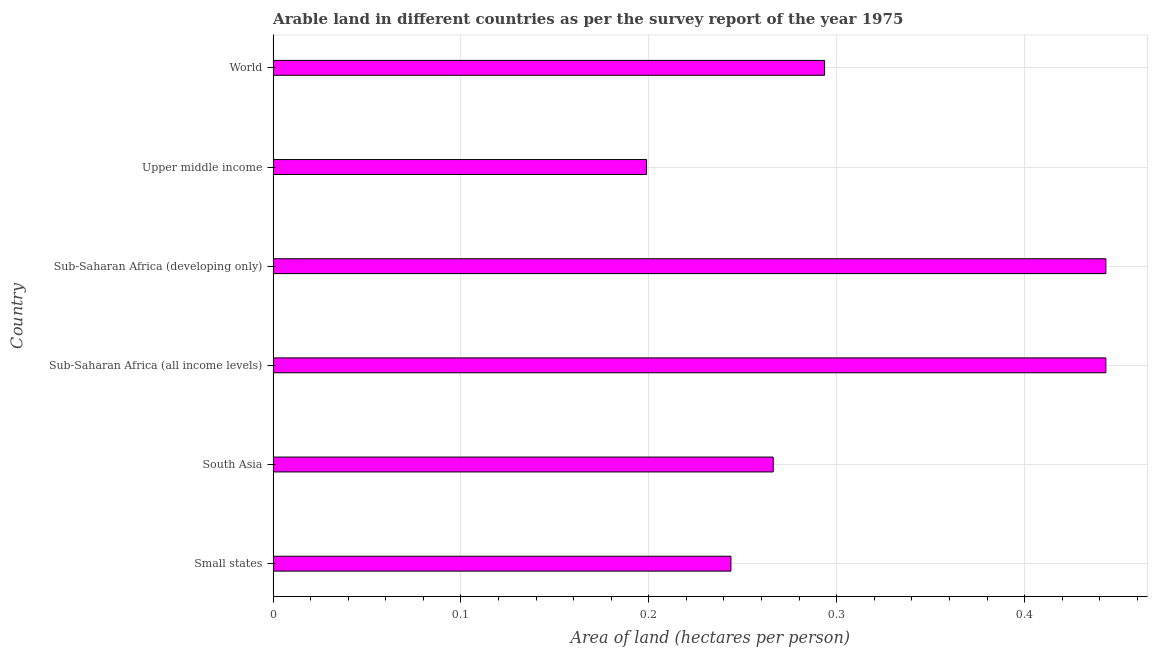Does the graph contain grids?
Offer a terse response. Yes. What is the title of the graph?
Offer a very short reply. Arable land in different countries as per the survey report of the year 1975. What is the label or title of the X-axis?
Ensure brevity in your answer.  Area of land (hectares per person). What is the label or title of the Y-axis?
Make the answer very short. Country. What is the area of arable land in Sub-Saharan Africa (developing only)?
Keep it short and to the point. 0.44. Across all countries, what is the maximum area of arable land?
Provide a short and direct response. 0.44. Across all countries, what is the minimum area of arable land?
Your response must be concise. 0.2. In which country was the area of arable land maximum?
Provide a succinct answer. Sub-Saharan Africa (developing only). In which country was the area of arable land minimum?
Offer a terse response. Upper middle income. What is the sum of the area of arable land?
Make the answer very short. 1.89. What is the difference between the area of arable land in Sub-Saharan Africa (all income levels) and Upper middle income?
Keep it short and to the point. 0.24. What is the average area of arable land per country?
Ensure brevity in your answer.  0.32. What is the median area of arable land?
Keep it short and to the point. 0.28. In how many countries, is the area of arable land greater than 0.24 hectares per person?
Your response must be concise. 5. What is the ratio of the area of arable land in Sub-Saharan Africa (all income levels) to that in World?
Your answer should be very brief. 1.51. Is the area of arable land in Upper middle income less than that in World?
Your response must be concise. Yes. Is the difference between the area of arable land in Small states and Sub-Saharan Africa (all income levels) greater than the difference between any two countries?
Offer a terse response. No. Is the sum of the area of arable land in Sub-Saharan Africa (all income levels) and Sub-Saharan Africa (developing only) greater than the maximum area of arable land across all countries?
Provide a short and direct response. Yes. What is the difference between the highest and the lowest area of arable land?
Give a very brief answer. 0.24. In how many countries, is the area of arable land greater than the average area of arable land taken over all countries?
Keep it short and to the point. 2. Are all the bars in the graph horizontal?
Your answer should be very brief. Yes. What is the Area of land (hectares per person) in Small states?
Your answer should be very brief. 0.24. What is the Area of land (hectares per person) in South Asia?
Your answer should be very brief. 0.27. What is the Area of land (hectares per person) of Sub-Saharan Africa (all income levels)?
Keep it short and to the point. 0.44. What is the Area of land (hectares per person) of Sub-Saharan Africa (developing only)?
Your answer should be very brief. 0.44. What is the Area of land (hectares per person) of Upper middle income?
Ensure brevity in your answer.  0.2. What is the Area of land (hectares per person) in World?
Offer a terse response. 0.29. What is the difference between the Area of land (hectares per person) in Small states and South Asia?
Your response must be concise. -0.02. What is the difference between the Area of land (hectares per person) in Small states and Sub-Saharan Africa (all income levels)?
Provide a succinct answer. -0.2. What is the difference between the Area of land (hectares per person) in Small states and Sub-Saharan Africa (developing only)?
Your answer should be very brief. -0.2. What is the difference between the Area of land (hectares per person) in Small states and Upper middle income?
Make the answer very short. 0.04. What is the difference between the Area of land (hectares per person) in Small states and World?
Ensure brevity in your answer.  -0.05. What is the difference between the Area of land (hectares per person) in South Asia and Sub-Saharan Africa (all income levels)?
Ensure brevity in your answer.  -0.18. What is the difference between the Area of land (hectares per person) in South Asia and Sub-Saharan Africa (developing only)?
Offer a terse response. -0.18. What is the difference between the Area of land (hectares per person) in South Asia and Upper middle income?
Provide a succinct answer. 0.07. What is the difference between the Area of land (hectares per person) in South Asia and World?
Your answer should be very brief. -0.03. What is the difference between the Area of land (hectares per person) in Sub-Saharan Africa (all income levels) and Upper middle income?
Your answer should be very brief. 0.24. What is the difference between the Area of land (hectares per person) in Sub-Saharan Africa (all income levels) and World?
Offer a terse response. 0.15. What is the difference between the Area of land (hectares per person) in Sub-Saharan Africa (developing only) and Upper middle income?
Provide a short and direct response. 0.24. What is the difference between the Area of land (hectares per person) in Sub-Saharan Africa (developing only) and World?
Your answer should be compact. 0.15. What is the difference between the Area of land (hectares per person) in Upper middle income and World?
Offer a terse response. -0.09. What is the ratio of the Area of land (hectares per person) in Small states to that in South Asia?
Ensure brevity in your answer.  0.92. What is the ratio of the Area of land (hectares per person) in Small states to that in Sub-Saharan Africa (all income levels)?
Give a very brief answer. 0.55. What is the ratio of the Area of land (hectares per person) in Small states to that in Sub-Saharan Africa (developing only)?
Give a very brief answer. 0.55. What is the ratio of the Area of land (hectares per person) in Small states to that in Upper middle income?
Ensure brevity in your answer.  1.23. What is the ratio of the Area of land (hectares per person) in Small states to that in World?
Offer a very short reply. 0.83. What is the ratio of the Area of land (hectares per person) in South Asia to that in Sub-Saharan Africa (all income levels)?
Offer a very short reply. 0.6. What is the ratio of the Area of land (hectares per person) in South Asia to that in Sub-Saharan Africa (developing only)?
Make the answer very short. 0.6. What is the ratio of the Area of land (hectares per person) in South Asia to that in Upper middle income?
Your answer should be very brief. 1.34. What is the ratio of the Area of land (hectares per person) in South Asia to that in World?
Your answer should be very brief. 0.91. What is the ratio of the Area of land (hectares per person) in Sub-Saharan Africa (all income levels) to that in Upper middle income?
Your response must be concise. 2.23. What is the ratio of the Area of land (hectares per person) in Sub-Saharan Africa (all income levels) to that in World?
Offer a very short reply. 1.51. What is the ratio of the Area of land (hectares per person) in Sub-Saharan Africa (developing only) to that in Upper middle income?
Offer a terse response. 2.23. What is the ratio of the Area of land (hectares per person) in Sub-Saharan Africa (developing only) to that in World?
Give a very brief answer. 1.51. What is the ratio of the Area of land (hectares per person) in Upper middle income to that in World?
Provide a succinct answer. 0.68. 